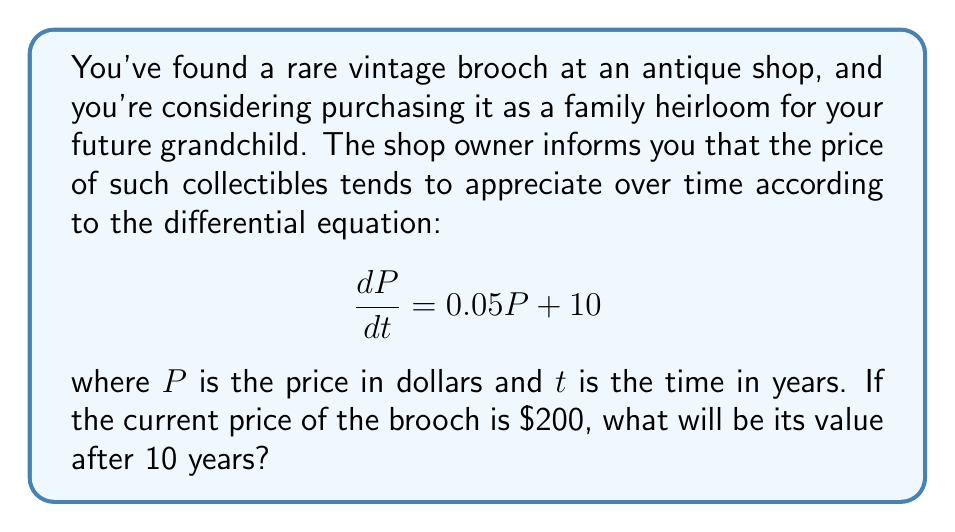Provide a solution to this math problem. To solve this problem, we need to use the method for solving first-order linear differential equations.

1) The general form of a first-order linear differential equation is:

   $$\frac{dP}{dt} + P(t)P = Q(t)$$

   In our case, $P(t) = -0.05$ and $Q(t) = 10$

2) The integrating factor is $e^{\int P(t)dt} = e^{-0.05t}$

3) Multiplying both sides of the equation by the integrating factor:

   $$e^{-0.05t}\frac{dP}{dt} + 0.05e^{-0.05t}P = 10e^{-0.05t}$$

4) The left side is now the derivative of $Pe^{-0.05t}$, so we can write:

   $$\frac{d}{dt}(Pe^{-0.05t}) = 10e^{-0.05t}$$

5) Integrating both sides:

   $$Pe^{-0.05t} = -200e^{-0.05t} + C$$

6) Solving for P:

   $$P = -200 + Ce^{0.05t}$$

7) Using the initial condition $P(0) = 200$, we can find C:

   $$200 = -200 + C$$
   $$C = 400$$

8) Therefore, the general solution is:

   $$P = -200 + 400e^{0.05t}$$

9) To find the price after 10 years, we substitute $t = 10$:

   $$P(10) = -200 + 400e^{0.5} \approx 526.49$$
Answer: The value of the brooch after 10 years will be approximately $526.49. 